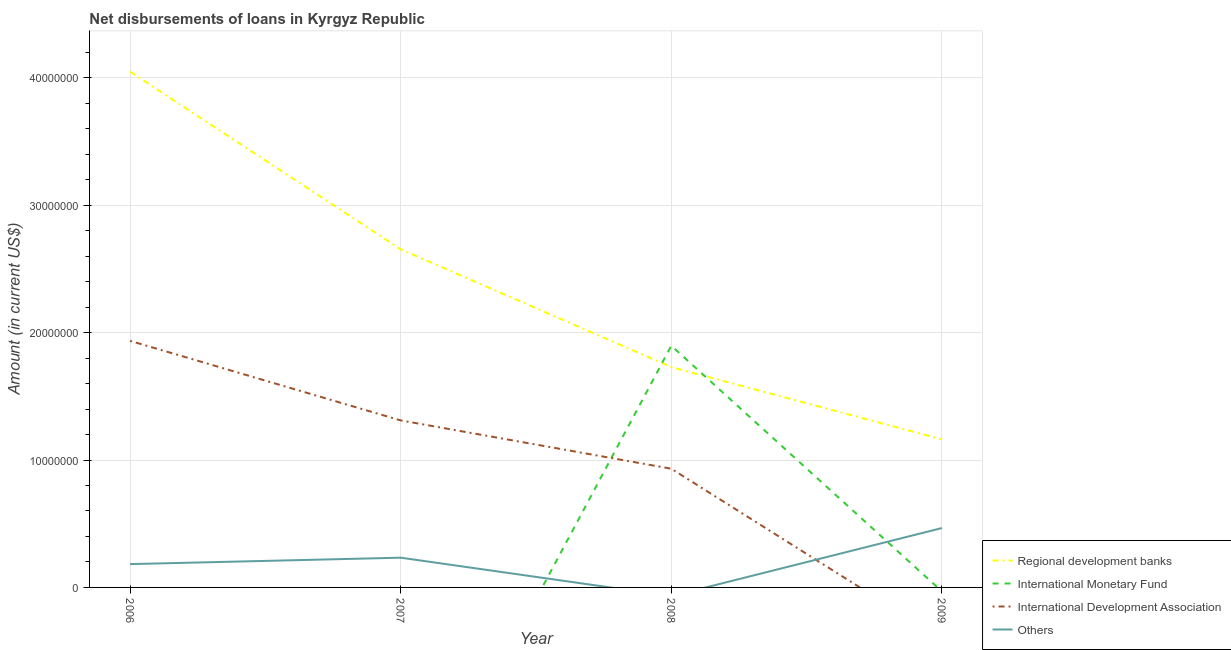How many different coloured lines are there?
Your answer should be compact. 4. Is the number of lines equal to the number of legend labels?
Your response must be concise. No. What is the amount of loan disimbursed by international development association in 2006?
Keep it short and to the point. 1.94e+07. Across all years, what is the maximum amount of loan disimbursed by international monetary fund?
Offer a terse response. 1.90e+07. Across all years, what is the minimum amount of loan disimbursed by regional development banks?
Keep it short and to the point. 1.16e+07. What is the total amount of loan disimbursed by other organisations in the graph?
Keep it short and to the point. 8.83e+06. What is the difference between the amount of loan disimbursed by regional development banks in 2006 and that in 2008?
Offer a terse response. 2.32e+07. What is the difference between the amount of loan disimbursed by regional development banks in 2009 and the amount of loan disimbursed by international development association in 2008?
Give a very brief answer. 2.30e+06. What is the average amount of loan disimbursed by international monetary fund per year?
Your answer should be very brief. 4.74e+06. In the year 2006, what is the difference between the amount of loan disimbursed by other organisations and amount of loan disimbursed by international development association?
Your answer should be very brief. -1.75e+07. What is the ratio of the amount of loan disimbursed by regional development banks in 2006 to that in 2009?
Give a very brief answer. 3.48. Is the difference between the amount of loan disimbursed by regional development banks in 2006 and 2007 greater than the difference between the amount of loan disimbursed by international development association in 2006 and 2007?
Offer a terse response. Yes. What is the difference between the highest and the second highest amount of loan disimbursed by regional development banks?
Provide a short and direct response. 1.39e+07. What is the difference between the highest and the lowest amount of loan disimbursed by other organisations?
Your answer should be compact. 4.66e+06. In how many years, is the amount of loan disimbursed by international monetary fund greater than the average amount of loan disimbursed by international monetary fund taken over all years?
Provide a succinct answer. 1. Is the sum of the amount of loan disimbursed by international development association in 2006 and 2008 greater than the maximum amount of loan disimbursed by international monetary fund across all years?
Your response must be concise. Yes. Does the amount of loan disimbursed by regional development banks monotonically increase over the years?
Provide a short and direct response. No. How many lines are there?
Your answer should be very brief. 4. What is the difference between two consecutive major ticks on the Y-axis?
Your answer should be very brief. 1.00e+07. Does the graph contain grids?
Offer a terse response. Yes. How many legend labels are there?
Offer a very short reply. 4. How are the legend labels stacked?
Your answer should be compact. Vertical. What is the title of the graph?
Provide a succinct answer. Net disbursements of loans in Kyrgyz Republic. Does "UNPBF" appear as one of the legend labels in the graph?
Your answer should be compact. No. What is the Amount (in current US$) of Regional development banks in 2006?
Provide a short and direct response. 4.05e+07. What is the Amount (in current US$) of International Development Association in 2006?
Keep it short and to the point. 1.94e+07. What is the Amount (in current US$) in Others in 2006?
Provide a short and direct response. 1.83e+06. What is the Amount (in current US$) of Regional development banks in 2007?
Give a very brief answer. 2.65e+07. What is the Amount (in current US$) in International Monetary Fund in 2007?
Your response must be concise. 0. What is the Amount (in current US$) of International Development Association in 2007?
Your answer should be very brief. 1.31e+07. What is the Amount (in current US$) of Others in 2007?
Give a very brief answer. 2.34e+06. What is the Amount (in current US$) of Regional development banks in 2008?
Your answer should be compact. 1.73e+07. What is the Amount (in current US$) of International Monetary Fund in 2008?
Keep it short and to the point. 1.90e+07. What is the Amount (in current US$) of International Development Association in 2008?
Ensure brevity in your answer.  9.32e+06. What is the Amount (in current US$) in Others in 2008?
Your answer should be very brief. 0. What is the Amount (in current US$) of Regional development banks in 2009?
Offer a very short reply. 1.16e+07. What is the Amount (in current US$) of International Development Association in 2009?
Offer a terse response. 0. What is the Amount (in current US$) of Others in 2009?
Offer a very short reply. 4.66e+06. Across all years, what is the maximum Amount (in current US$) of Regional development banks?
Keep it short and to the point. 4.05e+07. Across all years, what is the maximum Amount (in current US$) of International Monetary Fund?
Offer a terse response. 1.90e+07. Across all years, what is the maximum Amount (in current US$) of International Development Association?
Your response must be concise. 1.94e+07. Across all years, what is the maximum Amount (in current US$) in Others?
Offer a terse response. 4.66e+06. Across all years, what is the minimum Amount (in current US$) in Regional development banks?
Your answer should be very brief. 1.16e+07. Across all years, what is the minimum Amount (in current US$) in International Monetary Fund?
Your answer should be compact. 0. Across all years, what is the minimum Amount (in current US$) in International Development Association?
Your response must be concise. 0. Across all years, what is the minimum Amount (in current US$) in Others?
Your answer should be very brief. 0. What is the total Amount (in current US$) of Regional development banks in the graph?
Keep it short and to the point. 9.59e+07. What is the total Amount (in current US$) of International Monetary Fund in the graph?
Ensure brevity in your answer.  1.90e+07. What is the total Amount (in current US$) of International Development Association in the graph?
Your response must be concise. 4.18e+07. What is the total Amount (in current US$) of Others in the graph?
Your answer should be compact. 8.83e+06. What is the difference between the Amount (in current US$) in Regional development banks in 2006 and that in 2007?
Keep it short and to the point. 1.39e+07. What is the difference between the Amount (in current US$) in International Development Association in 2006 and that in 2007?
Provide a short and direct response. 6.24e+06. What is the difference between the Amount (in current US$) in Others in 2006 and that in 2007?
Keep it short and to the point. -5.05e+05. What is the difference between the Amount (in current US$) of Regional development banks in 2006 and that in 2008?
Your answer should be very brief. 2.32e+07. What is the difference between the Amount (in current US$) in International Development Association in 2006 and that in 2008?
Provide a succinct answer. 1.00e+07. What is the difference between the Amount (in current US$) of Regional development banks in 2006 and that in 2009?
Offer a very short reply. 2.89e+07. What is the difference between the Amount (in current US$) of Others in 2006 and that in 2009?
Offer a terse response. -2.83e+06. What is the difference between the Amount (in current US$) in Regional development banks in 2007 and that in 2008?
Your answer should be compact. 9.25e+06. What is the difference between the Amount (in current US$) in International Development Association in 2007 and that in 2008?
Make the answer very short. 3.79e+06. What is the difference between the Amount (in current US$) in Regional development banks in 2007 and that in 2009?
Make the answer very short. 1.49e+07. What is the difference between the Amount (in current US$) in Others in 2007 and that in 2009?
Make the answer very short. -2.33e+06. What is the difference between the Amount (in current US$) of Regional development banks in 2008 and that in 2009?
Your response must be concise. 5.67e+06. What is the difference between the Amount (in current US$) of Regional development banks in 2006 and the Amount (in current US$) of International Development Association in 2007?
Ensure brevity in your answer.  2.74e+07. What is the difference between the Amount (in current US$) of Regional development banks in 2006 and the Amount (in current US$) of Others in 2007?
Your answer should be compact. 3.82e+07. What is the difference between the Amount (in current US$) in International Development Association in 2006 and the Amount (in current US$) in Others in 2007?
Offer a very short reply. 1.70e+07. What is the difference between the Amount (in current US$) in Regional development banks in 2006 and the Amount (in current US$) in International Monetary Fund in 2008?
Offer a terse response. 2.15e+07. What is the difference between the Amount (in current US$) in Regional development banks in 2006 and the Amount (in current US$) in International Development Association in 2008?
Make the answer very short. 3.12e+07. What is the difference between the Amount (in current US$) of Regional development banks in 2006 and the Amount (in current US$) of Others in 2009?
Make the answer very short. 3.58e+07. What is the difference between the Amount (in current US$) in International Development Association in 2006 and the Amount (in current US$) in Others in 2009?
Make the answer very short. 1.47e+07. What is the difference between the Amount (in current US$) in Regional development banks in 2007 and the Amount (in current US$) in International Monetary Fund in 2008?
Offer a very short reply. 7.57e+06. What is the difference between the Amount (in current US$) of Regional development banks in 2007 and the Amount (in current US$) of International Development Association in 2008?
Provide a short and direct response. 1.72e+07. What is the difference between the Amount (in current US$) in Regional development banks in 2007 and the Amount (in current US$) in Others in 2009?
Give a very brief answer. 2.19e+07. What is the difference between the Amount (in current US$) of International Development Association in 2007 and the Amount (in current US$) of Others in 2009?
Ensure brevity in your answer.  8.45e+06. What is the difference between the Amount (in current US$) of Regional development banks in 2008 and the Amount (in current US$) of Others in 2009?
Ensure brevity in your answer.  1.26e+07. What is the difference between the Amount (in current US$) in International Monetary Fund in 2008 and the Amount (in current US$) in Others in 2009?
Your answer should be compact. 1.43e+07. What is the difference between the Amount (in current US$) of International Development Association in 2008 and the Amount (in current US$) of Others in 2009?
Provide a succinct answer. 4.66e+06. What is the average Amount (in current US$) in Regional development banks per year?
Your answer should be very brief. 2.40e+07. What is the average Amount (in current US$) in International Monetary Fund per year?
Your answer should be very brief. 4.74e+06. What is the average Amount (in current US$) of International Development Association per year?
Your answer should be compact. 1.04e+07. What is the average Amount (in current US$) of Others per year?
Your response must be concise. 2.21e+06. In the year 2006, what is the difference between the Amount (in current US$) of Regional development banks and Amount (in current US$) of International Development Association?
Offer a terse response. 2.11e+07. In the year 2006, what is the difference between the Amount (in current US$) in Regional development banks and Amount (in current US$) in Others?
Offer a terse response. 3.87e+07. In the year 2006, what is the difference between the Amount (in current US$) in International Development Association and Amount (in current US$) in Others?
Offer a terse response. 1.75e+07. In the year 2007, what is the difference between the Amount (in current US$) in Regional development banks and Amount (in current US$) in International Development Association?
Offer a terse response. 1.34e+07. In the year 2007, what is the difference between the Amount (in current US$) of Regional development banks and Amount (in current US$) of Others?
Give a very brief answer. 2.42e+07. In the year 2007, what is the difference between the Amount (in current US$) of International Development Association and Amount (in current US$) of Others?
Your answer should be very brief. 1.08e+07. In the year 2008, what is the difference between the Amount (in current US$) of Regional development banks and Amount (in current US$) of International Monetary Fund?
Provide a short and direct response. -1.68e+06. In the year 2008, what is the difference between the Amount (in current US$) in Regional development banks and Amount (in current US$) in International Development Association?
Your response must be concise. 7.98e+06. In the year 2008, what is the difference between the Amount (in current US$) in International Monetary Fund and Amount (in current US$) in International Development Association?
Offer a very short reply. 9.66e+06. In the year 2009, what is the difference between the Amount (in current US$) in Regional development banks and Amount (in current US$) in Others?
Provide a short and direct response. 6.96e+06. What is the ratio of the Amount (in current US$) of Regional development banks in 2006 to that in 2007?
Your answer should be very brief. 1.53. What is the ratio of the Amount (in current US$) in International Development Association in 2006 to that in 2007?
Keep it short and to the point. 1.48. What is the ratio of the Amount (in current US$) of Others in 2006 to that in 2007?
Keep it short and to the point. 0.78. What is the ratio of the Amount (in current US$) in Regional development banks in 2006 to that in 2008?
Your response must be concise. 2.34. What is the ratio of the Amount (in current US$) in International Development Association in 2006 to that in 2008?
Your answer should be compact. 2.08. What is the ratio of the Amount (in current US$) of Regional development banks in 2006 to that in 2009?
Your answer should be compact. 3.48. What is the ratio of the Amount (in current US$) in Others in 2006 to that in 2009?
Provide a succinct answer. 0.39. What is the ratio of the Amount (in current US$) in Regional development banks in 2007 to that in 2008?
Your answer should be very brief. 1.53. What is the ratio of the Amount (in current US$) of International Development Association in 2007 to that in 2008?
Your response must be concise. 1.41. What is the ratio of the Amount (in current US$) in Regional development banks in 2007 to that in 2009?
Provide a short and direct response. 2.28. What is the ratio of the Amount (in current US$) in Others in 2007 to that in 2009?
Provide a short and direct response. 0.5. What is the ratio of the Amount (in current US$) of Regional development banks in 2008 to that in 2009?
Provide a succinct answer. 1.49. What is the difference between the highest and the second highest Amount (in current US$) in Regional development banks?
Make the answer very short. 1.39e+07. What is the difference between the highest and the second highest Amount (in current US$) in International Development Association?
Keep it short and to the point. 6.24e+06. What is the difference between the highest and the second highest Amount (in current US$) of Others?
Your answer should be compact. 2.33e+06. What is the difference between the highest and the lowest Amount (in current US$) in Regional development banks?
Your answer should be very brief. 2.89e+07. What is the difference between the highest and the lowest Amount (in current US$) of International Monetary Fund?
Offer a very short reply. 1.90e+07. What is the difference between the highest and the lowest Amount (in current US$) of International Development Association?
Ensure brevity in your answer.  1.94e+07. What is the difference between the highest and the lowest Amount (in current US$) of Others?
Provide a succinct answer. 4.66e+06. 